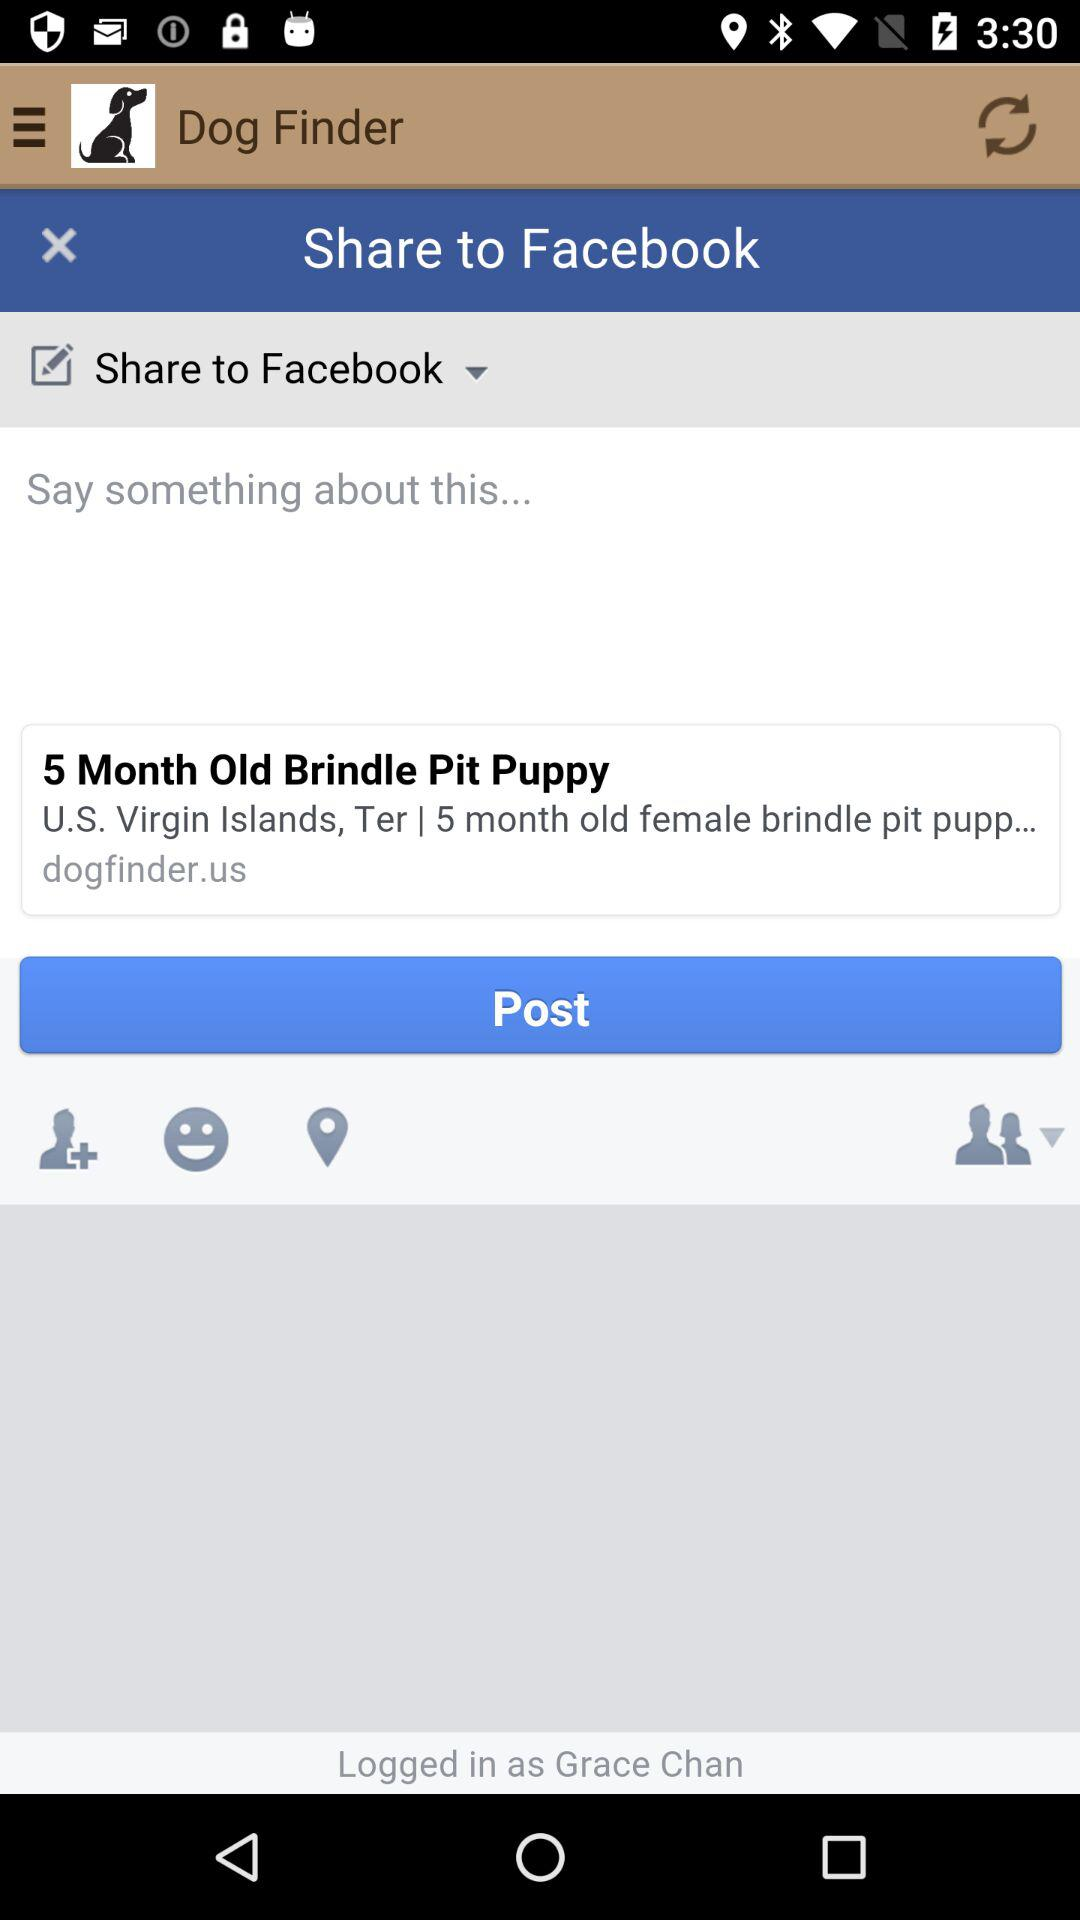What is the login name? The login name is Grace Chan. 